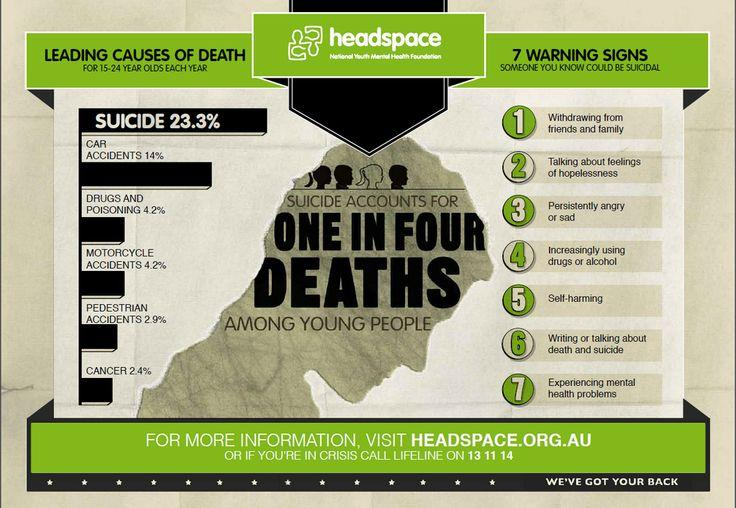List a handful of essential elements in this visual. The fifth warning sign listed here is self-harming," the doctor declared. According to a recent study, 14% of suicides are caused by car accidents. According to a recent study, only 2.9% of suicides are caused by pedestrian accidents. According to statistics, 4.2% of all suicides are caused by motorcycle accidents. 